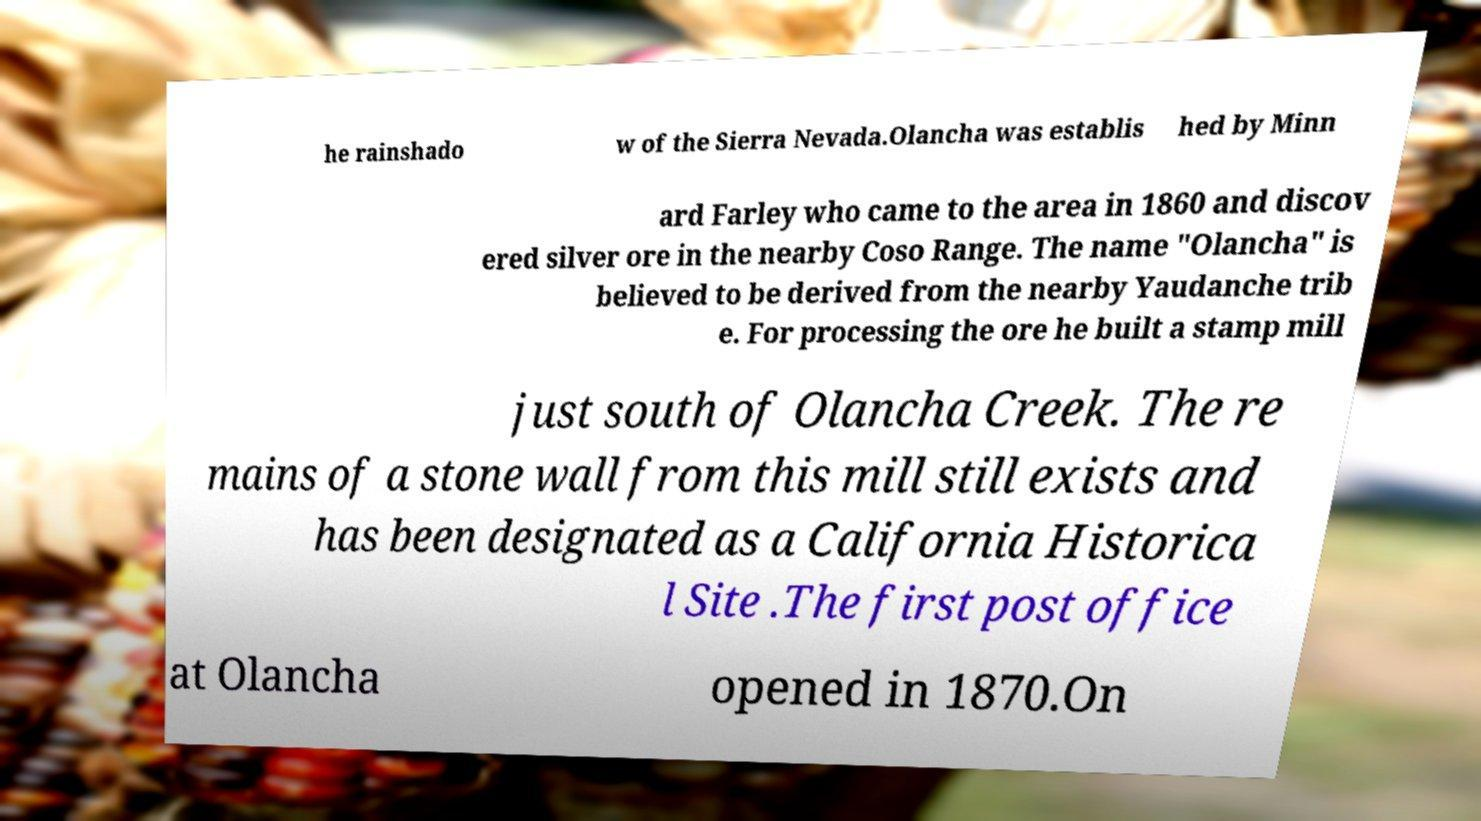Could you assist in decoding the text presented in this image and type it out clearly? he rainshado w of the Sierra Nevada.Olancha was establis hed by Minn ard Farley who came to the area in 1860 and discov ered silver ore in the nearby Coso Range. The name "Olancha" is believed to be derived from the nearby Yaudanche trib e. For processing the ore he built a stamp mill just south of Olancha Creek. The re mains of a stone wall from this mill still exists and has been designated as a California Historica l Site .The first post office at Olancha opened in 1870.On 